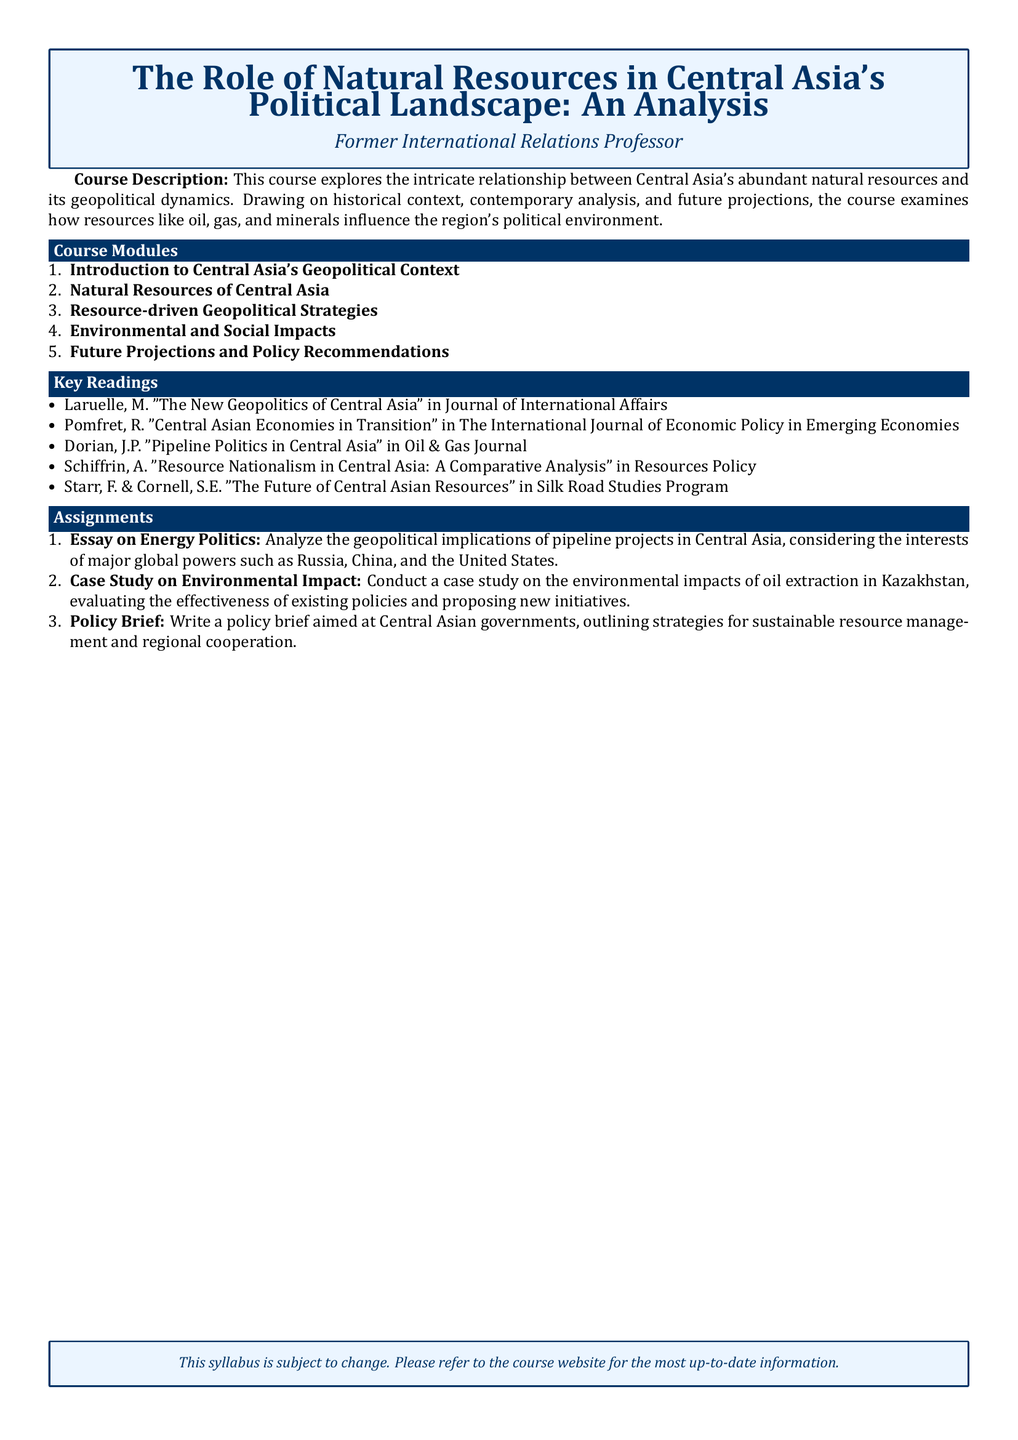What is the title of the course? The title is the main heading of the syllabus, providing insight into the course's focus on natural resources and politics in Central Asia.
Answer: The Role of Natural Resources in Central Asia's Political Landscape: An Analysis Who is the intended audience for this course? The intended audience is specified in the course description, indicating the professional background of the course creator.
Answer: Former International Relations Professor What is the first module of the course? The first module is the starting point of the course content overview and provides context for the geopolitical study of Central Asia.
Answer: Introduction to Central Asia's Geopolitical Context How many key readings are listed in the syllabus? The number of key readings provides insight into the research and literature that supports the course content.
Answer: Five What is one of the assignments mentioned in the syllabus? The assignments offer practical applications of the course material, showing how students are expected to engage with the content.
Answer: Essay on Energy Politics What publication features the reading by Schiffrin, A.? The publication information is important for identifying where to find the cited work related to resource nationalism in Central Asia.
Answer: Resources Policy What is the color of the box used for the course title? The box color for the title creates visual interest and sets the theme for the syllabus.
Answer: Dark blue What is the purpose of the policy brief assignment? This question seeks to understand the expected output of the assignment and its relevance to real-world issues in the region.
Answer: Sustainable resource management and regional cooperation What does the document suggest about its syllabus content? This part addresses any potential changes that may occur during the course, indicating the dynamic nature of the syllabus.
Answer: Subject to change 